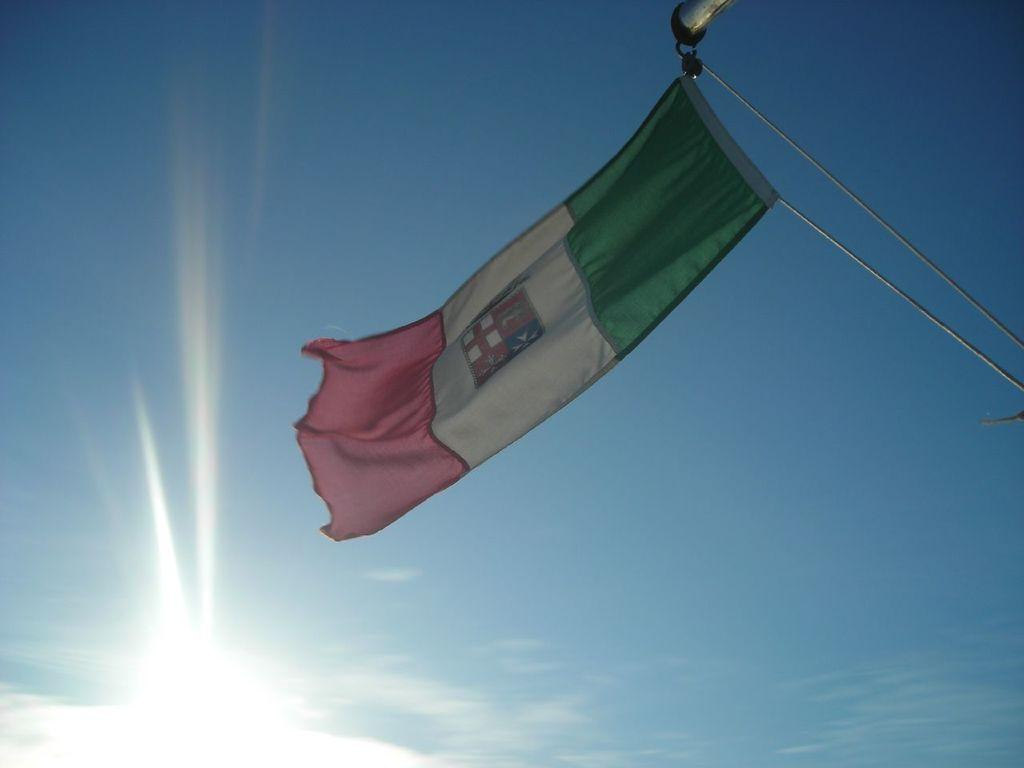What is the main object in the image? There is a flag in the image. What type of vessel is being crushed by the flag in the image? There is no vessel present in the image, and the flag is not crushing anything. 